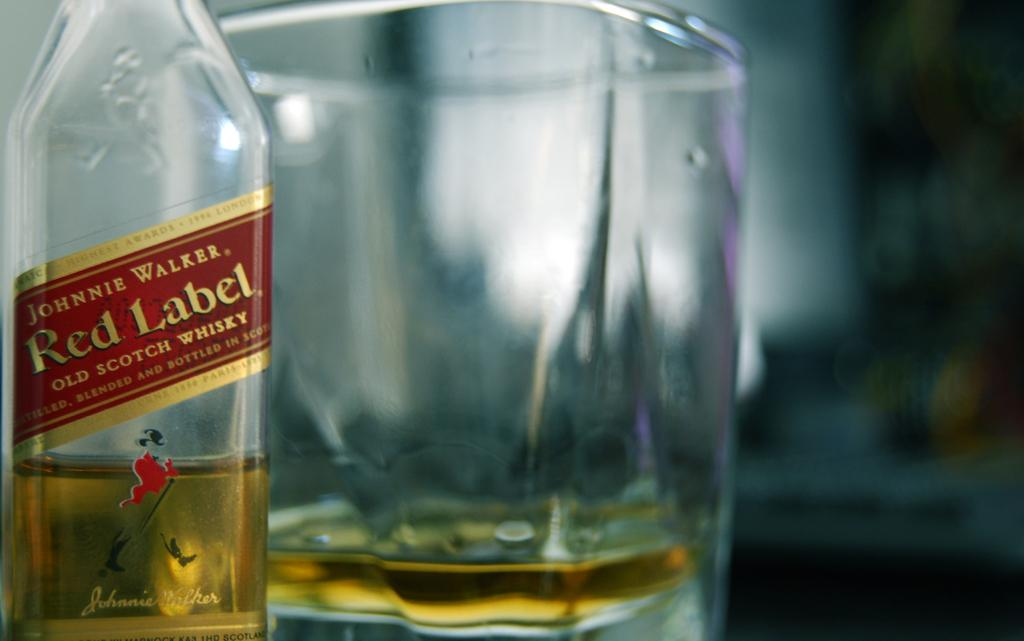<image>
Write a terse but informative summary of the picture. A bottle of Johnnie Walker Red label sits by an ampty glass 